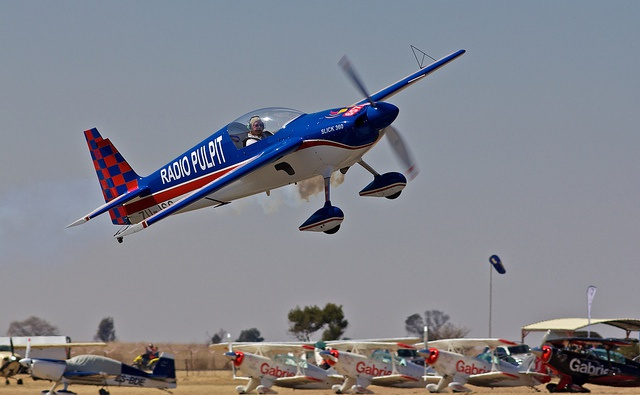Describe the objects in this image and their specific colors. I can see airplane in gray, black, darkgray, and navy tones, airplane in gray and darkgray tones, airplane in gray and darkgray tones, airplane in gray, black, and maroon tones, and airplane in gray, black, and maroon tones in this image. 